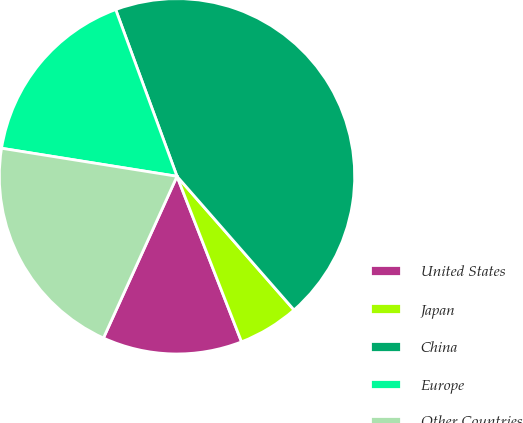Convert chart. <chart><loc_0><loc_0><loc_500><loc_500><pie_chart><fcel>United States<fcel>Japan<fcel>China<fcel>Europe<fcel>Other Countries<nl><fcel>12.71%<fcel>5.53%<fcel>44.16%<fcel>16.87%<fcel>20.73%<nl></chart> 